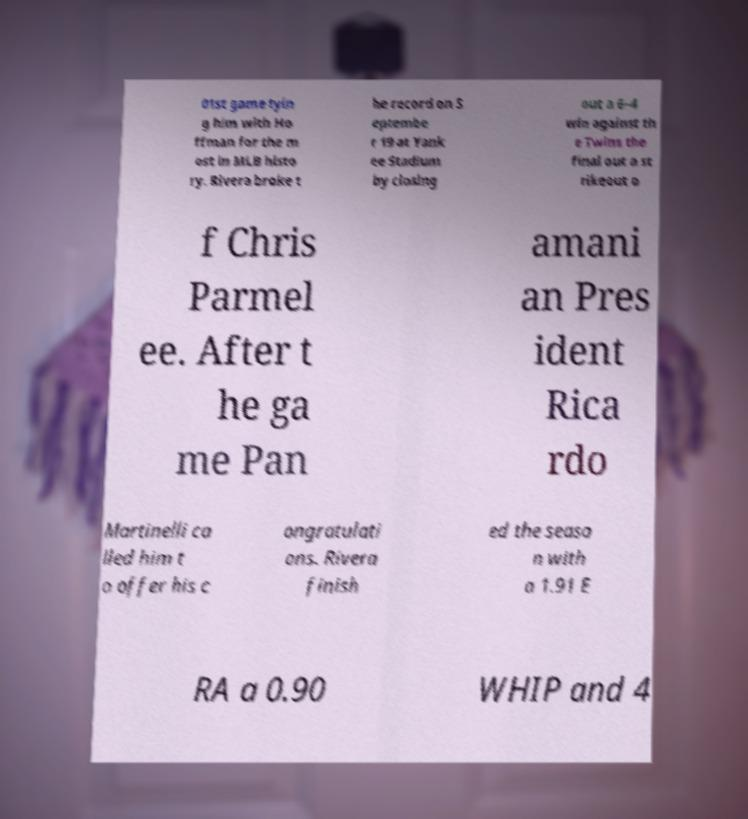Could you assist in decoding the text presented in this image and type it out clearly? 01st game tyin g him with Ho ffman for the m ost in MLB histo ry. Rivera broke t he record on S eptembe r 19 at Yank ee Stadium by closing out a 6–4 win against th e Twins the final out a st rikeout o f Chris Parmel ee. After t he ga me Pan amani an Pres ident Rica rdo Martinelli ca lled him t o offer his c ongratulati ons. Rivera finish ed the seaso n with a 1.91 E RA a 0.90 WHIP and 4 